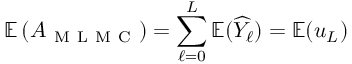Convert formula to latex. <formula><loc_0><loc_0><loc_500><loc_500>\mathbb { E } \left ( A _ { M L M C } \right ) = \sum _ { \ell = 0 } ^ { L } \mathbb { E } ( \widehat { Y } _ { \ell } ) = \mathbb { E } ( u _ { L } )</formula> 